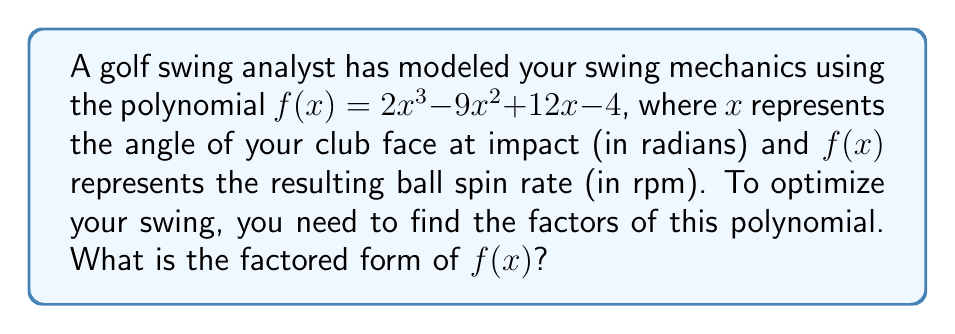Help me with this question. Let's approach this step-by-step:

1) First, we need to check if there are any common factors. In this case, there are none.

2) Next, we can try to guess one of the factors. Since the constant term is -4, possible factors are ±1, ±2, ±4. Let's try these:

   $f(1) = 2(1)^3 - 9(1)^2 + 12(1) - 4 = 2 - 9 + 12 - 4 = 1$
   $f(2) = 2(2)^3 - 9(2)^2 + 12(2) - 4 = 16 - 36 + 24 - 4 = 0$

3) We've found that $(x-2)$ is a factor. Let's use polynomial long division to find the other factor:

   $$\frac{2x^3 - 9x^2 + 12x - 4}{x - 2} = 2x^2 - 5x + 2$$

4) So, $f(x) = (x-2)(2x^2 - 5x + 2)$

5) Now, let's try to factor the quadratic term $2x^2 - 5x + 2$:
   
   a = 2, b = -5, c = 2
   
   Discriminant = $b^2 - 4ac = (-5)^2 - 4(2)(2) = 25 - 16 = 9$
   
   Roots = $\frac{-b \pm \sqrt{b^2-4ac}}{2a} = \frac{5 \pm 3}{4}$

   So, the roots are $\frac{1}{2}$ and $2$

6) Therefore, $2x^2 - 5x + 2 = 2(x - \frac{1}{2})(x - 2)$

7) Putting it all together:

   $f(x) = (x-2)(2x^2 - 5x + 2) = 2(x-2)(x - \frac{1}{2})(x - 2)$

   $f(x) = 2(x-2)^2(x - \frac{1}{2})$
Answer: $2(x-2)^2(x - \frac{1}{2})$ 